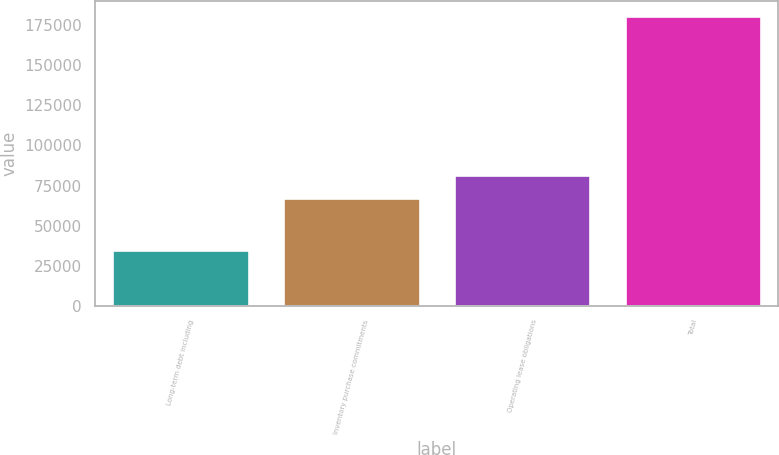Convert chart to OTSL. <chart><loc_0><loc_0><loc_500><loc_500><bar_chart><fcel>Long-term debt including<fcel>Inventory purchase commitments<fcel>Operating lease obligations<fcel>Total<nl><fcel>34660<fcel>67245<fcel>81864.6<fcel>180856<nl></chart> 